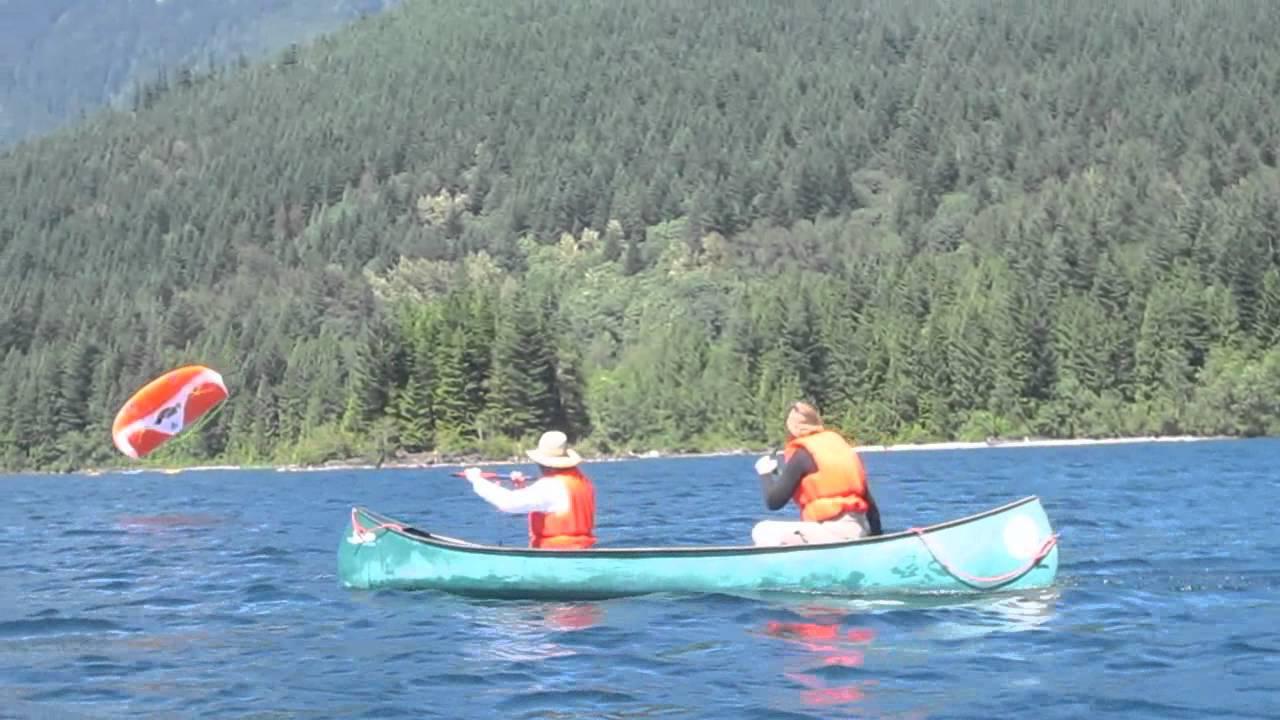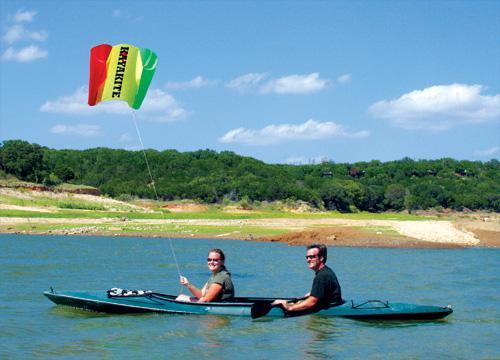The first image is the image on the left, the second image is the image on the right. Evaluate the accuracy of this statement regarding the images: "There are people using red paddles.". Is it true? Answer yes or no. No. The first image is the image on the left, the second image is the image on the right. Examine the images to the left and right. Is the description "Multiple canoes are headed away from the camera in one image." accurate? Answer yes or no. No. 